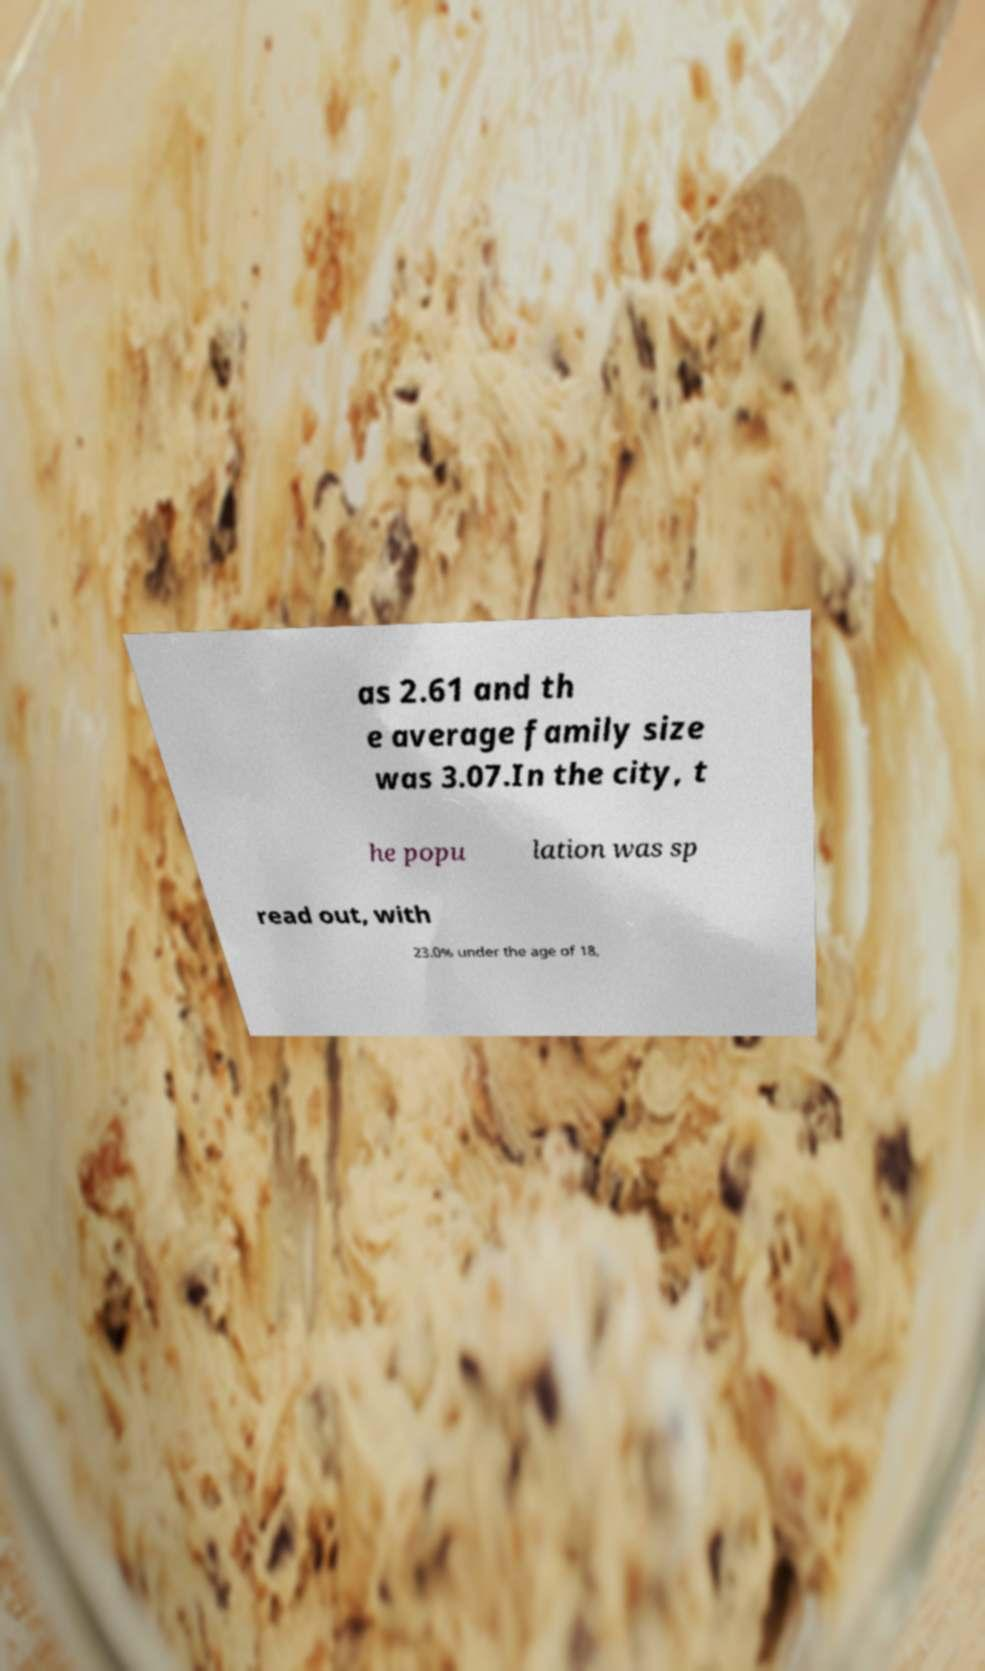For documentation purposes, I need the text within this image transcribed. Could you provide that? as 2.61 and th e average family size was 3.07.In the city, t he popu lation was sp read out, with 23.0% under the age of 18, 